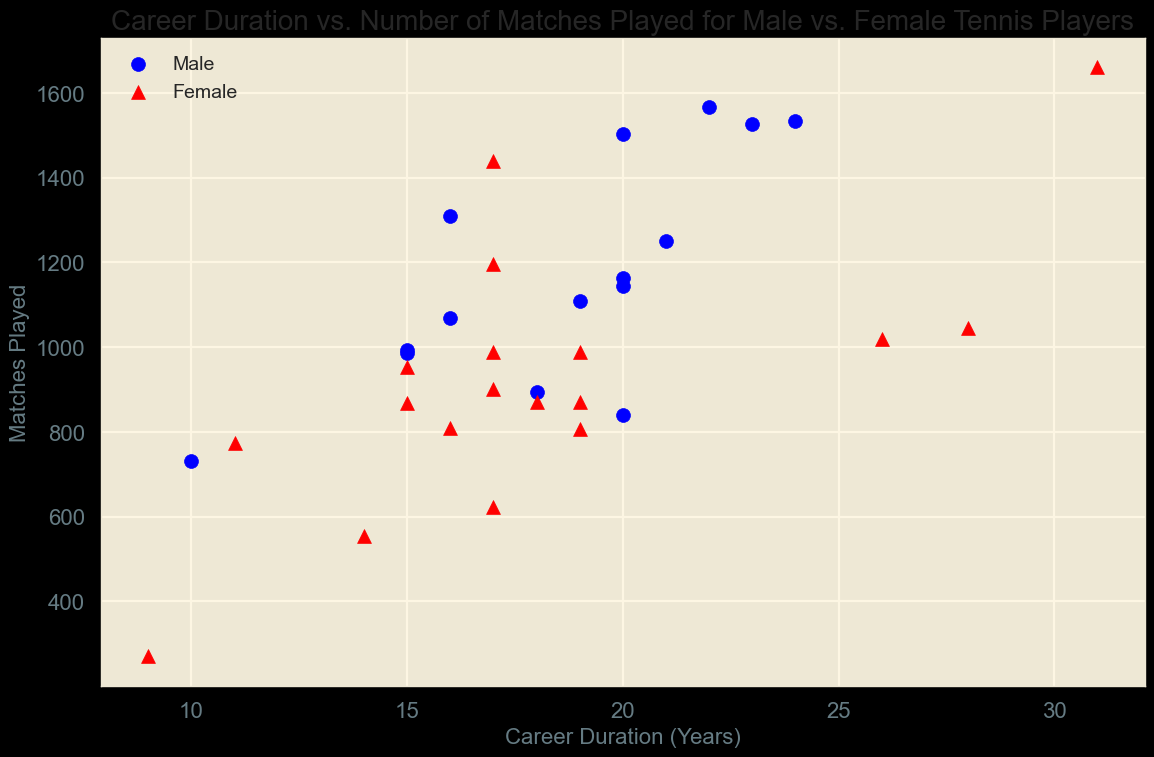Which player has the longest career duration? By looking at the x-axis (Career Duration in Years) and identifying which point is farthest to the right, we can see Martina Navratilova's data point at 31 years.
Answer: Martina Navratilova Which female player has played the most matches, and how long was her career? By identifying the highest red triangle (matches played by female players) on the y-axis and checking the corresponding x-value, Martina Navratilova played 1661 matches over a 31-year career.
Answer: Martina Navratilova, 31 years Who has the shortest career duration among the male players, and how many matches did he play? The male player with the shortest career duration is identified by finding the blue circle closest to the origin (smallest x-axis value). Bjorn Borg had a 10-year career and played 731 matches.
Answer: Bjorn Borg, 731 matches Compare the average career duration of male and female players. Average career duration for male players: (23+21+20+15+10+20+22+15+20+16+24+18+20+19+16) / 15 = 18.53 years. For female players: (26+28+17+31+17+17+19+15+9+16+11+17+19+14+18+19) / 16 = 18.25 years.
Answer: Male: 18.53 years, Female: 18.25 years Which player has played the most matches, and what is the duration of their career? The player with the most matches is the one with the highest point on the y-axis. Martina Navratilova played 1661 matches over a 31-year career.
Answer: Martina Navratilova, 31 years How many female players have a career duration of 20 years or more? Counting the number of red triangles to the right of the 20-year mark on the x-axis, there are 3 female players: Serena Williams, Venus Williams, and Martina Navratilova.
Answer: 3 What is the ratio of the longest male career duration to the longest female career duration? The longest male career duration is Jimmy Connors at 24 years, and the longest female career duration is Martina Navratilova at 31 years. The ratio is 24/31 = 0.774.
Answer: 0.774 Who has a longer career duration: Roger Federer or Steffi Graf? By identifying their points (Roger Federer's blue circle and Steffi Graf's red triangle) on the x-axis, Roger Federer has a career duration of 23 years and Steffi Graf has 17 years.
Answer: Roger Federer Compare the total matches played by male players vs. female players (sum). Summing up matches played by male players: 1526+1251+1163+987+731+1144+1568+993+1504+1310+1535+894+840+1110+1070 = 18726. Summing up matches played by female players: 1020+1046+902+1661+1440+1197+988+954+270+810+773+989+806+869+623+555+870+870 = 17633.
Answer: Male: 18726, Female: 17633 Identify the player with the shortest career duration and the fewest matches played. Finding the point closest to the origin on both axes, Naomi Osaka has the shortest career duration (9 years) with 270 matches.
Answer: Naomi Osaka, 270 matches 